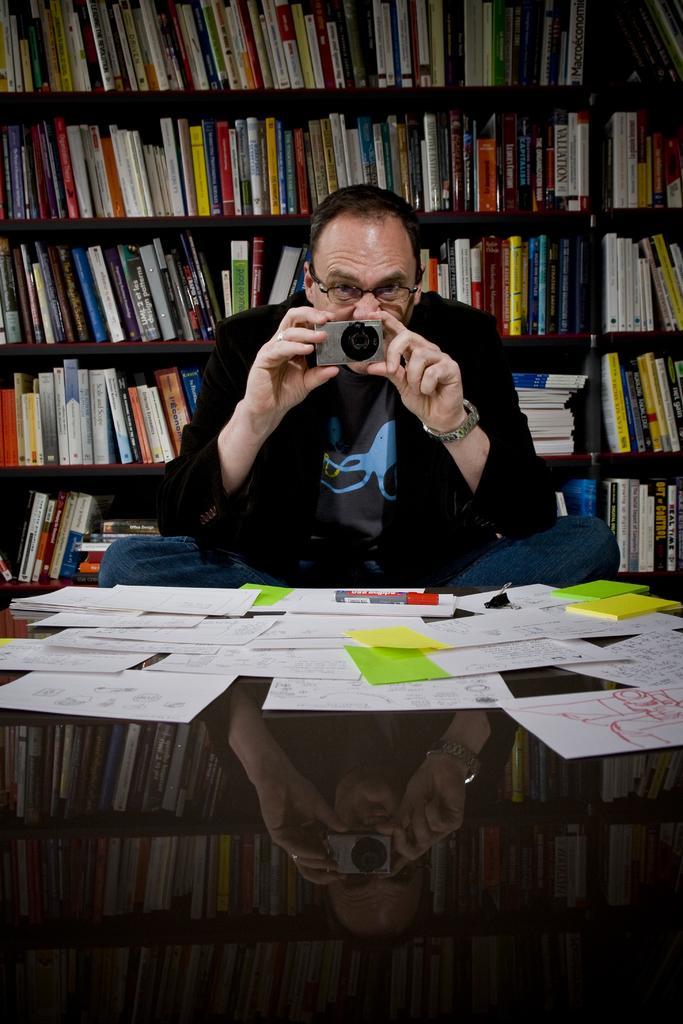How would you summarize this image in a sentence or two? In this picture I can see papers, marker and a binder clip on the table, there is a man sitting and holding a camera, and in the background there are books in the racks. 